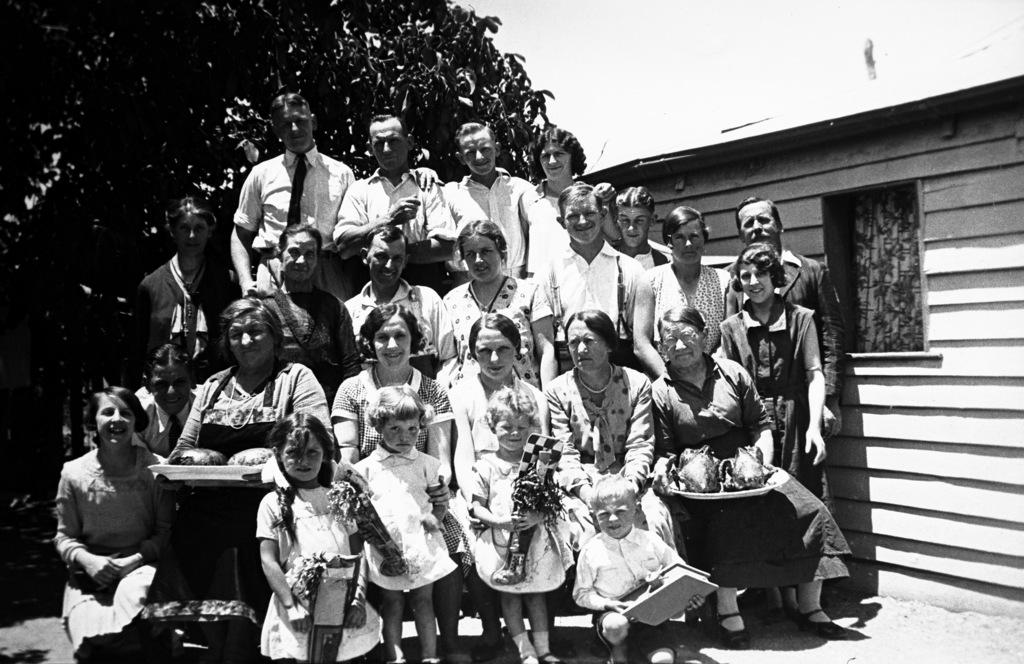What are the women in the image doing? There are women seated and standing in the image. Can you describe the setting of the image? There is a house and a tree in the image. What type of writing can be seen on the bells in the image? There are no bells present in the image, so no writing can be seen on them. 